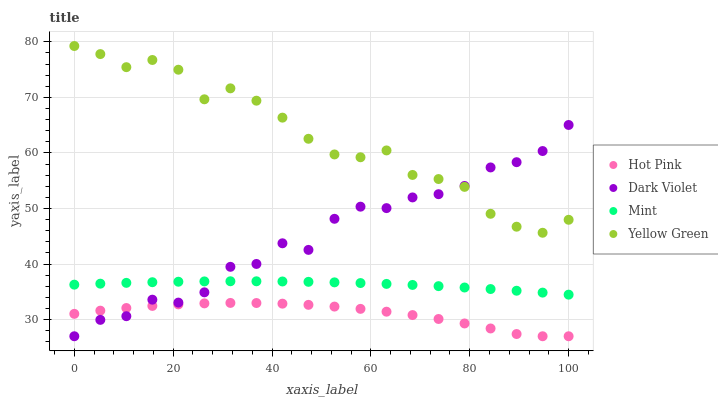Does Hot Pink have the minimum area under the curve?
Answer yes or no. Yes. Does Yellow Green have the maximum area under the curve?
Answer yes or no. Yes. Does Mint have the minimum area under the curve?
Answer yes or no. No. Does Mint have the maximum area under the curve?
Answer yes or no. No. Is Mint the smoothest?
Answer yes or no. Yes. Is Dark Violet the roughest?
Answer yes or no. Yes. Is Yellow Green the smoothest?
Answer yes or no. No. Is Yellow Green the roughest?
Answer yes or no. No. Does Hot Pink have the lowest value?
Answer yes or no. Yes. Does Mint have the lowest value?
Answer yes or no. No. Does Yellow Green have the highest value?
Answer yes or no. Yes. Does Mint have the highest value?
Answer yes or no. No. Is Hot Pink less than Mint?
Answer yes or no. Yes. Is Mint greater than Hot Pink?
Answer yes or no. Yes. Does Dark Violet intersect Yellow Green?
Answer yes or no. Yes. Is Dark Violet less than Yellow Green?
Answer yes or no. No. Is Dark Violet greater than Yellow Green?
Answer yes or no. No. Does Hot Pink intersect Mint?
Answer yes or no. No. 